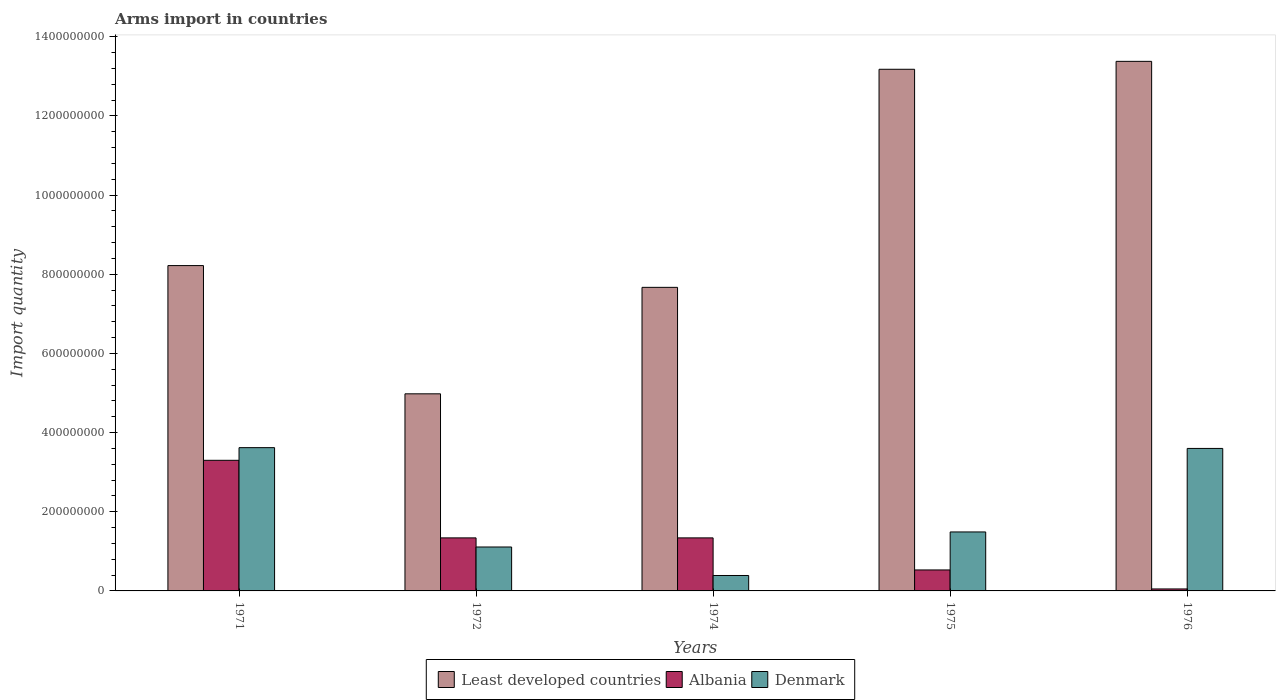How many different coloured bars are there?
Your answer should be compact. 3. Are the number of bars per tick equal to the number of legend labels?
Provide a short and direct response. Yes. How many bars are there on the 3rd tick from the right?
Offer a terse response. 3. What is the label of the 5th group of bars from the left?
Your answer should be compact. 1976. What is the total arms import in Least developed countries in 1972?
Keep it short and to the point. 4.98e+08. Across all years, what is the maximum total arms import in Least developed countries?
Your answer should be very brief. 1.34e+09. Across all years, what is the minimum total arms import in Denmark?
Your answer should be compact. 3.90e+07. In which year was the total arms import in Denmark maximum?
Your answer should be compact. 1971. In which year was the total arms import in Denmark minimum?
Give a very brief answer. 1974. What is the total total arms import in Denmark in the graph?
Keep it short and to the point. 1.02e+09. What is the difference between the total arms import in Denmark in 1971 and that in 1974?
Ensure brevity in your answer.  3.23e+08. What is the difference between the total arms import in Least developed countries in 1975 and the total arms import in Denmark in 1972?
Keep it short and to the point. 1.21e+09. What is the average total arms import in Least developed countries per year?
Offer a terse response. 9.49e+08. In the year 1976, what is the difference between the total arms import in Albania and total arms import in Least developed countries?
Provide a short and direct response. -1.33e+09. In how many years, is the total arms import in Denmark greater than 1000000000?
Keep it short and to the point. 0. What is the ratio of the total arms import in Albania in 1972 to that in 1976?
Your answer should be very brief. 26.8. Is the total arms import in Albania in 1972 less than that in 1975?
Ensure brevity in your answer.  No. What is the difference between the highest and the second highest total arms import in Albania?
Offer a terse response. 1.96e+08. What is the difference between the highest and the lowest total arms import in Denmark?
Ensure brevity in your answer.  3.23e+08. What does the 1st bar from the left in 1976 represents?
Provide a short and direct response. Least developed countries. How many years are there in the graph?
Make the answer very short. 5. Are the values on the major ticks of Y-axis written in scientific E-notation?
Your response must be concise. No. Does the graph contain any zero values?
Offer a very short reply. No. How many legend labels are there?
Give a very brief answer. 3. How are the legend labels stacked?
Offer a terse response. Horizontal. What is the title of the graph?
Provide a succinct answer. Arms import in countries. What is the label or title of the Y-axis?
Offer a very short reply. Import quantity. What is the Import quantity of Least developed countries in 1971?
Your answer should be very brief. 8.22e+08. What is the Import quantity of Albania in 1971?
Keep it short and to the point. 3.30e+08. What is the Import quantity of Denmark in 1971?
Your response must be concise. 3.62e+08. What is the Import quantity in Least developed countries in 1972?
Your answer should be compact. 4.98e+08. What is the Import quantity in Albania in 1972?
Your response must be concise. 1.34e+08. What is the Import quantity of Denmark in 1972?
Give a very brief answer. 1.11e+08. What is the Import quantity in Least developed countries in 1974?
Offer a terse response. 7.67e+08. What is the Import quantity of Albania in 1974?
Your answer should be compact. 1.34e+08. What is the Import quantity in Denmark in 1974?
Your answer should be compact. 3.90e+07. What is the Import quantity of Least developed countries in 1975?
Offer a very short reply. 1.32e+09. What is the Import quantity of Albania in 1975?
Ensure brevity in your answer.  5.30e+07. What is the Import quantity in Denmark in 1975?
Provide a succinct answer. 1.49e+08. What is the Import quantity of Least developed countries in 1976?
Your answer should be compact. 1.34e+09. What is the Import quantity in Albania in 1976?
Give a very brief answer. 5.00e+06. What is the Import quantity of Denmark in 1976?
Provide a succinct answer. 3.60e+08. Across all years, what is the maximum Import quantity in Least developed countries?
Provide a succinct answer. 1.34e+09. Across all years, what is the maximum Import quantity in Albania?
Offer a terse response. 3.30e+08. Across all years, what is the maximum Import quantity of Denmark?
Provide a short and direct response. 3.62e+08. Across all years, what is the minimum Import quantity in Least developed countries?
Ensure brevity in your answer.  4.98e+08. Across all years, what is the minimum Import quantity of Denmark?
Keep it short and to the point. 3.90e+07. What is the total Import quantity in Least developed countries in the graph?
Your answer should be very brief. 4.74e+09. What is the total Import quantity in Albania in the graph?
Keep it short and to the point. 6.56e+08. What is the total Import quantity in Denmark in the graph?
Your answer should be compact. 1.02e+09. What is the difference between the Import quantity in Least developed countries in 1971 and that in 1972?
Your answer should be compact. 3.24e+08. What is the difference between the Import quantity in Albania in 1971 and that in 1972?
Provide a succinct answer. 1.96e+08. What is the difference between the Import quantity of Denmark in 1971 and that in 1972?
Your response must be concise. 2.51e+08. What is the difference between the Import quantity of Least developed countries in 1971 and that in 1974?
Your response must be concise. 5.50e+07. What is the difference between the Import quantity in Albania in 1971 and that in 1974?
Give a very brief answer. 1.96e+08. What is the difference between the Import quantity of Denmark in 1971 and that in 1974?
Provide a short and direct response. 3.23e+08. What is the difference between the Import quantity of Least developed countries in 1971 and that in 1975?
Ensure brevity in your answer.  -4.96e+08. What is the difference between the Import quantity in Albania in 1971 and that in 1975?
Your answer should be very brief. 2.77e+08. What is the difference between the Import quantity in Denmark in 1971 and that in 1975?
Provide a short and direct response. 2.13e+08. What is the difference between the Import quantity of Least developed countries in 1971 and that in 1976?
Keep it short and to the point. -5.16e+08. What is the difference between the Import quantity of Albania in 1971 and that in 1976?
Offer a terse response. 3.25e+08. What is the difference between the Import quantity of Denmark in 1971 and that in 1976?
Your answer should be very brief. 2.00e+06. What is the difference between the Import quantity of Least developed countries in 1972 and that in 1974?
Your answer should be compact. -2.69e+08. What is the difference between the Import quantity of Denmark in 1972 and that in 1974?
Give a very brief answer. 7.20e+07. What is the difference between the Import quantity in Least developed countries in 1972 and that in 1975?
Give a very brief answer. -8.20e+08. What is the difference between the Import quantity of Albania in 1972 and that in 1975?
Offer a very short reply. 8.10e+07. What is the difference between the Import quantity of Denmark in 1972 and that in 1975?
Offer a very short reply. -3.80e+07. What is the difference between the Import quantity of Least developed countries in 1972 and that in 1976?
Offer a terse response. -8.40e+08. What is the difference between the Import quantity in Albania in 1972 and that in 1976?
Give a very brief answer. 1.29e+08. What is the difference between the Import quantity in Denmark in 1972 and that in 1976?
Your response must be concise. -2.49e+08. What is the difference between the Import quantity of Least developed countries in 1974 and that in 1975?
Provide a short and direct response. -5.51e+08. What is the difference between the Import quantity of Albania in 1974 and that in 1975?
Your answer should be compact. 8.10e+07. What is the difference between the Import quantity in Denmark in 1974 and that in 1975?
Your response must be concise. -1.10e+08. What is the difference between the Import quantity in Least developed countries in 1974 and that in 1976?
Provide a succinct answer. -5.71e+08. What is the difference between the Import quantity in Albania in 1974 and that in 1976?
Keep it short and to the point. 1.29e+08. What is the difference between the Import quantity of Denmark in 1974 and that in 1976?
Ensure brevity in your answer.  -3.21e+08. What is the difference between the Import quantity in Least developed countries in 1975 and that in 1976?
Offer a terse response. -2.00e+07. What is the difference between the Import quantity in Albania in 1975 and that in 1976?
Ensure brevity in your answer.  4.80e+07. What is the difference between the Import quantity of Denmark in 1975 and that in 1976?
Give a very brief answer. -2.11e+08. What is the difference between the Import quantity in Least developed countries in 1971 and the Import quantity in Albania in 1972?
Give a very brief answer. 6.88e+08. What is the difference between the Import quantity in Least developed countries in 1971 and the Import quantity in Denmark in 1972?
Provide a short and direct response. 7.11e+08. What is the difference between the Import quantity of Albania in 1971 and the Import quantity of Denmark in 1972?
Your answer should be very brief. 2.19e+08. What is the difference between the Import quantity of Least developed countries in 1971 and the Import quantity of Albania in 1974?
Your answer should be very brief. 6.88e+08. What is the difference between the Import quantity of Least developed countries in 1971 and the Import quantity of Denmark in 1974?
Provide a short and direct response. 7.83e+08. What is the difference between the Import quantity of Albania in 1971 and the Import quantity of Denmark in 1974?
Keep it short and to the point. 2.91e+08. What is the difference between the Import quantity in Least developed countries in 1971 and the Import quantity in Albania in 1975?
Provide a succinct answer. 7.69e+08. What is the difference between the Import quantity in Least developed countries in 1971 and the Import quantity in Denmark in 1975?
Keep it short and to the point. 6.73e+08. What is the difference between the Import quantity of Albania in 1971 and the Import quantity of Denmark in 1975?
Provide a short and direct response. 1.81e+08. What is the difference between the Import quantity in Least developed countries in 1971 and the Import quantity in Albania in 1976?
Provide a short and direct response. 8.17e+08. What is the difference between the Import quantity of Least developed countries in 1971 and the Import quantity of Denmark in 1976?
Provide a succinct answer. 4.62e+08. What is the difference between the Import quantity of Albania in 1971 and the Import quantity of Denmark in 1976?
Your response must be concise. -3.00e+07. What is the difference between the Import quantity of Least developed countries in 1972 and the Import quantity of Albania in 1974?
Provide a short and direct response. 3.64e+08. What is the difference between the Import quantity in Least developed countries in 1972 and the Import quantity in Denmark in 1974?
Make the answer very short. 4.59e+08. What is the difference between the Import quantity of Albania in 1972 and the Import quantity of Denmark in 1974?
Provide a short and direct response. 9.50e+07. What is the difference between the Import quantity of Least developed countries in 1972 and the Import quantity of Albania in 1975?
Your answer should be very brief. 4.45e+08. What is the difference between the Import quantity in Least developed countries in 1972 and the Import quantity in Denmark in 1975?
Your answer should be compact. 3.49e+08. What is the difference between the Import quantity of Albania in 1972 and the Import quantity of Denmark in 1975?
Ensure brevity in your answer.  -1.50e+07. What is the difference between the Import quantity in Least developed countries in 1972 and the Import quantity in Albania in 1976?
Offer a very short reply. 4.93e+08. What is the difference between the Import quantity of Least developed countries in 1972 and the Import quantity of Denmark in 1976?
Ensure brevity in your answer.  1.38e+08. What is the difference between the Import quantity in Albania in 1972 and the Import quantity in Denmark in 1976?
Your response must be concise. -2.26e+08. What is the difference between the Import quantity in Least developed countries in 1974 and the Import quantity in Albania in 1975?
Keep it short and to the point. 7.14e+08. What is the difference between the Import quantity of Least developed countries in 1974 and the Import quantity of Denmark in 1975?
Your answer should be very brief. 6.18e+08. What is the difference between the Import quantity in Albania in 1974 and the Import quantity in Denmark in 1975?
Your answer should be compact. -1.50e+07. What is the difference between the Import quantity of Least developed countries in 1974 and the Import quantity of Albania in 1976?
Your answer should be compact. 7.62e+08. What is the difference between the Import quantity in Least developed countries in 1974 and the Import quantity in Denmark in 1976?
Offer a very short reply. 4.07e+08. What is the difference between the Import quantity in Albania in 1974 and the Import quantity in Denmark in 1976?
Provide a short and direct response. -2.26e+08. What is the difference between the Import quantity of Least developed countries in 1975 and the Import quantity of Albania in 1976?
Make the answer very short. 1.31e+09. What is the difference between the Import quantity in Least developed countries in 1975 and the Import quantity in Denmark in 1976?
Provide a succinct answer. 9.58e+08. What is the difference between the Import quantity of Albania in 1975 and the Import quantity of Denmark in 1976?
Ensure brevity in your answer.  -3.07e+08. What is the average Import quantity of Least developed countries per year?
Offer a very short reply. 9.49e+08. What is the average Import quantity of Albania per year?
Keep it short and to the point. 1.31e+08. What is the average Import quantity in Denmark per year?
Ensure brevity in your answer.  2.04e+08. In the year 1971, what is the difference between the Import quantity of Least developed countries and Import quantity of Albania?
Make the answer very short. 4.92e+08. In the year 1971, what is the difference between the Import quantity of Least developed countries and Import quantity of Denmark?
Offer a very short reply. 4.60e+08. In the year 1971, what is the difference between the Import quantity in Albania and Import quantity in Denmark?
Your response must be concise. -3.20e+07. In the year 1972, what is the difference between the Import quantity of Least developed countries and Import quantity of Albania?
Your answer should be very brief. 3.64e+08. In the year 1972, what is the difference between the Import quantity of Least developed countries and Import quantity of Denmark?
Offer a very short reply. 3.87e+08. In the year 1972, what is the difference between the Import quantity in Albania and Import quantity in Denmark?
Offer a very short reply. 2.30e+07. In the year 1974, what is the difference between the Import quantity of Least developed countries and Import quantity of Albania?
Ensure brevity in your answer.  6.33e+08. In the year 1974, what is the difference between the Import quantity in Least developed countries and Import quantity in Denmark?
Provide a succinct answer. 7.28e+08. In the year 1974, what is the difference between the Import quantity in Albania and Import quantity in Denmark?
Your answer should be compact. 9.50e+07. In the year 1975, what is the difference between the Import quantity in Least developed countries and Import quantity in Albania?
Make the answer very short. 1.26e+09. In the year 1975, what is the difference between the Import quantity of Least developed countries and Import quantity of Denmark?
Ensure brevity in your answer.  1.17e+09. In the year 1975, what is the difference between the Import quantity of Albania and Import quantity of Denmark?
Offer a terse response. -9.60e+07. In the year 1976, what is the difference between the Import quantity in Least developed countries and Import quantity in Albania?
Offer a terse response. 1.33e+09. In the year 1976, what is the difference between the Import quantity in Least developed countries and Import quantity in Denmark?
Offer a terse response. 9.78e+08. In the year 1976, what is the difference between the Import quantity in Albania and Import quantity in Denmark?
Offer a very short reply. -3.55e+08. What is the ratio of the Import quantity of Least developed countries in 1971 to that in 1972?
Ensure brevity in your answer.  1.65. What is the ratio of the Import quantity of Albania in 1971 to that in 1972?
Offer a terse response. 2.46. What is the ratio of the Import quantity in Denmark in 1971 to that in 1972?
Give a very brief answer. 3.26. What is the ratio of the Import quantity of Least developed countries in 1971 to that in 1974?
Ensure brevity in your answer.  1.07. What is the ratio of the Import quantity in Albania in 1971 to that in 1974?
Offer a very short reply. 2.46. What is the ratio of the Import quantity of Denmark in 1971 to that in 1974?
Ensure brevity in your answer.  9.28. What is the ratio of the Import quantity in Least developed countries in 1971 to that in 1975?
Provide a succinct answer. 0.62. What is the ratio of the Import quantity in Albania in 1971 to that in 1975?
Your answer should be very brief. 6.23. What is the ratio of the Import quantity of Denmark in 1971 to that in 1975?
Provide a short and direct response. 2.43. What is the ratio of the Import quantity in Least developed countries in 1971 to that in 1976?
Make the answer very short. 0.61. What is the ratio of the Import quantity of Denmark in 1971 to that in 1976?
Your answer should be very brief. 1.01. What is the ratio of the Import quantity in Least developed countries in 1972 to that in 1974?
Provide a short and direct response. 0.65. What is the ratio of the Import quantity in Albania in 1972 to that in 1974?
Provide a succinct answer. 1. What is the ratio of the Import quantity in Denmark in 1972 to that in 1974?
Offer a very short reply. 2.85. What is the ratio of the Import quantity of Least developed countries in 1972 to that in 1975?
Ensure brevity in your answer.  0.38. What is the ratio of the Import quantity of Albania in 1972 to that in 1975?
Your answer should be very brief. 2.53. What is the ratio of the Import quantity of Denmark in 1972 to that in 1975?
Offer a very short reply. 0.74. What is the ratio of the Import quantity of Least developed countries in 1972 to that in 1976?
Offer a terse response. 0.37. What is the ratio of the Import quantity of Albania in 1972 to that in 1976?
Keep it short and to the point. 26.8. What is the ratio of the Import quantity of Denmark in 1972 to that in 1976?
Offer a very short reply. 0.31. What is the ratio of the Import quantity in Least developed countries in 1974 to that in 1975?
Provide a short and direct response. 0.58. What is the ratio of the Import quantity of Albania in 1974 to that in 1975?
Provide a short and direct response. 2.53. What is the ratio of the Import quantity of Denmark in 1974 to that in 1975?
Your response must be concise. 0.26. What is the ratio of the Import quantity of Least developed countries in 1974 to that in 1976?
Offer a very short reply. 0.57. What is the ratio of the Import quantity in Albania in 1974 to that in 1976?
Provide a succinct answer. 26.8. What is the ratio of the Import quantity in Denmark in 1974 to that in 1976?
Ensure brevity in your answer.  0.11. What is the ratio of the Import quantity of Least developed countries in 1975 to that in 1976?
Your response must be concise. 0.99. What is the ratio of the Import quantity of Denmark in 1975 to that in 1976?
Ensure brevity in your answer.  0.41. What is the difference between the highest and the second highest Import quantity of Albania?
Offer a terse response. 1.96e+08. What is the difference between the highest and the second highest Import quantity of Denmark?
Your response must be concise. 2.00e+06. What is the difference between the highest and the lowest Import quantity in Least developed countries?
Ensure brevity in your answer.  8.40e+08. What is the difference between the highest and the lowest Import quantity of Albania?
Provide a short and direct response. 3.25e+08. What is the difference between the highest and the lowest Import quantity of Denmark?
Offer a terse response. 3.23e+08. 